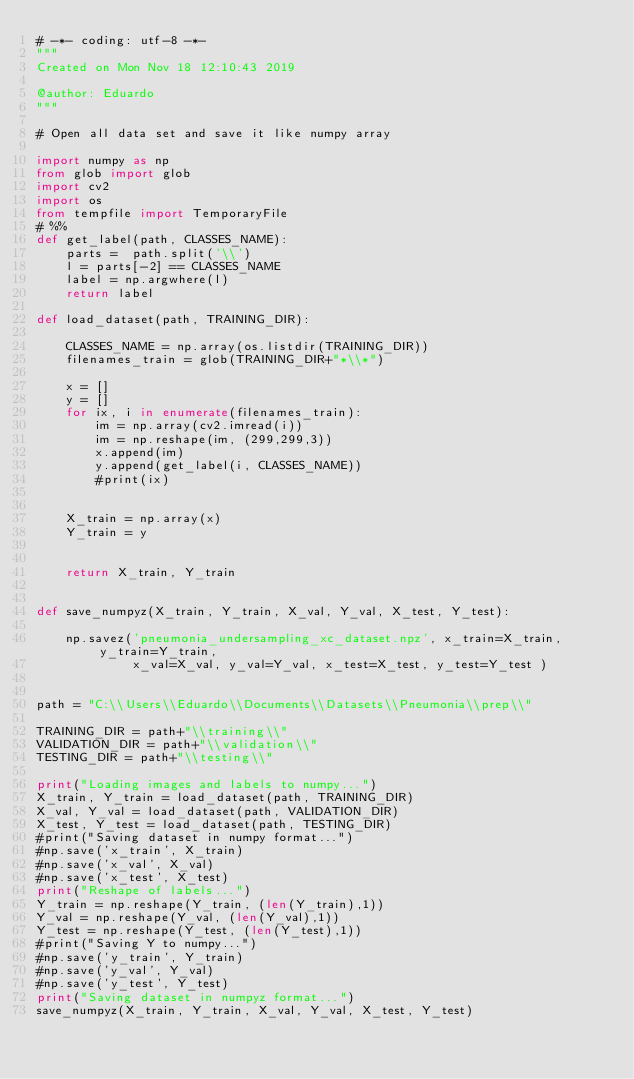Convert code to text. <code><loc_0><loc_0><loc_500><loc_500><_Python_># -*- coding: utf-8 -*-
"""
Created on Mon Nov 18 12:10:43 2019

@author: Eduardo
"""

# Open all data set and save it like numpy array

import numpy as np
from glob import glob
import cv2
import os
from tempfile import TemporaryFile
# %%
def get_label(path, CLASSES_NAME):
    parts =  path.split('\\')
    l = parts[-2] == CLASSES_NAME
    label = np.argwhere(l)
    return label

def load_dataset(path, TRAINING_DIR):

    CLASSES_NAME = np.array(os.listdir(TRAINING_DIR))
    filenames_train = glob(TRAINING_DIR+"*\\*")
    
    x = []
    y = []
    for ix, i in enumerate(filenames_train):
        im = np.array(cv2.imread(i))
        im = np.reshape(im, (299,299,3))
        x.append(im)
        y.append(get_label(i, CLASSES_NAME))
        #print(ix)

    
    X_train = np.array(x)
    Y_train = y
    
    
    return X_train, Y_train


def save_numpyz(X_train, Y_train, X_val, Y_val, X_test, Y_test):
    
    np.savez('pneumonia_undersampling_xc_dataset.npz', x_train=X_train, y_train=Y_train,
             x_val=X_val, y_val=Y_val, x_test=X_test, y_test=Y_test )
    
    
path = "C:\\Users\\Eduardo\\Documents\\Datasets\\Pneumonia\\prep\\" 

TRAINING_DIR = path+"\\training\\"
VALIDATION_DIR = path+"\\validation\\"
TESTING_DIR = path+"\\testing\\"

print("Loading images and labels to numpy...")
X_train, Y_train = load_dataset(path, TRAINING_DIR)
X_val, Y_val = load_dataset(path, VALIDATION_DIR)
X_test, Y_test = load_dataset(path, TESTING_DIR)
#print("Saving dataset in numpy format...")
#np.save('x_train', X_train)
#np.save('x_val', X_val)
#np.save('x_test', X_test)
print("Reshape of labels...")
Y_train = np.reshape(Y_train, (len(Y_train),1))
Y_val = np.reshape(Y_val, (len(Y_val),1))
Y_test = np.reshape(Y_test, (len(Y_test),1))
#print("Saving Y to numpy...")
#np.save('y_train', Y_train)
#np.save('y_val', Y_val)
#np.save('y_test', Y_test)
print("Saving dataset in numpyz format...")
save_numpyz(X_train, Y_train, X_val, Y_val, X_test, Y_test)   

</code> 